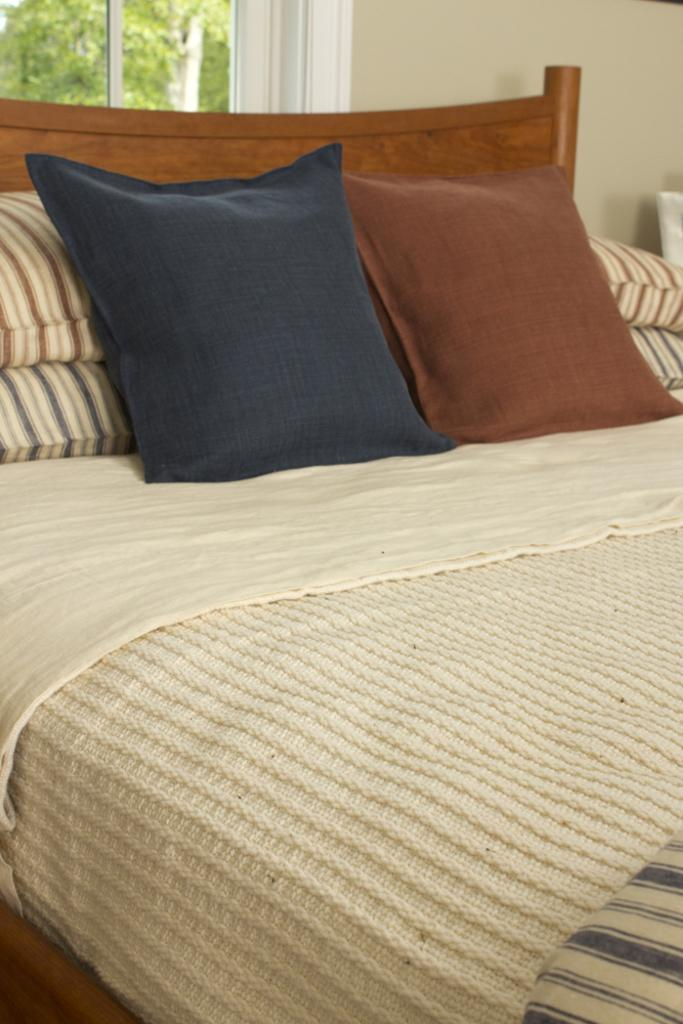What piece of furniture is present in the image? There is a bed in the image. What is on the bed? The bed has a pillow and a bed-sheet. What can be seen in the background of the image? There is a window and a tree visible in the background of the image. What type of rod is holding up the tree in the image? There is no rod holding up the tree in the image; it is a natural tree standing on its own. 